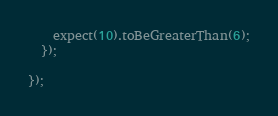Convert code to text. <code><loc_0><loc_0><loc_500><loc_500><_TypeScript_>    expect(10).toBeGreaterThan(6);
  });

});
</code> 